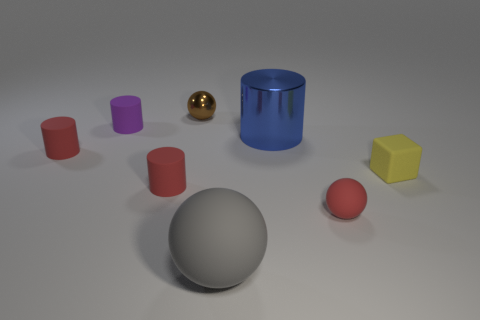How many big objects are gray things or yellow metallic balls? In the picture, there is one large gray sphere and alongside it, a smaller golden metallic sphere. There are no big objects that are yellow, but if you were referring to the golden sphere as yellow, then the total count of big gray objects and yellow (or golden) metallic balls would be two. 